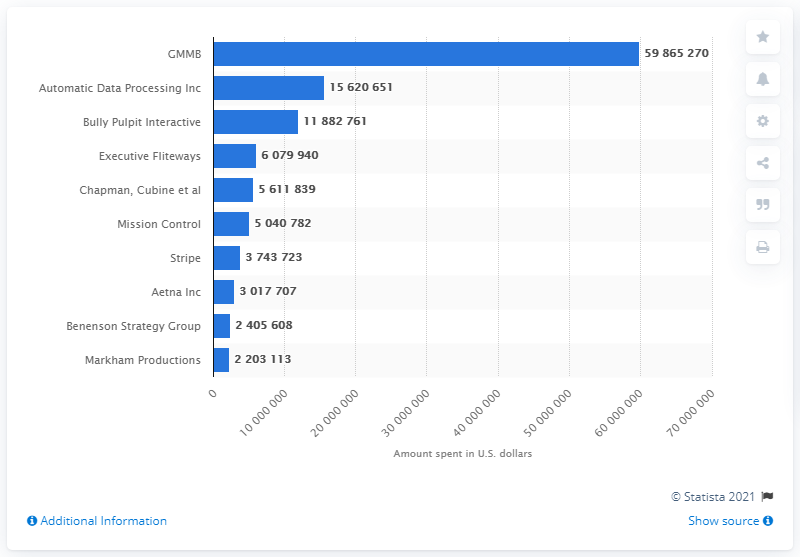Draw attention to some important aspects in this diagram. The Hillary Clinton campaign paid GMMB $59,865,270 as of August 2016. 